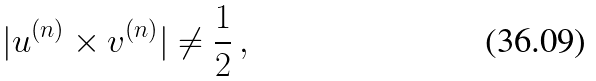<formula> <loc_0><loc_0><loc_500><loc_500>| u ^ { ( n ) } \times v ^ { ( n ) } | \neq \frac { 1 } { 2 } \, ,</formula> 